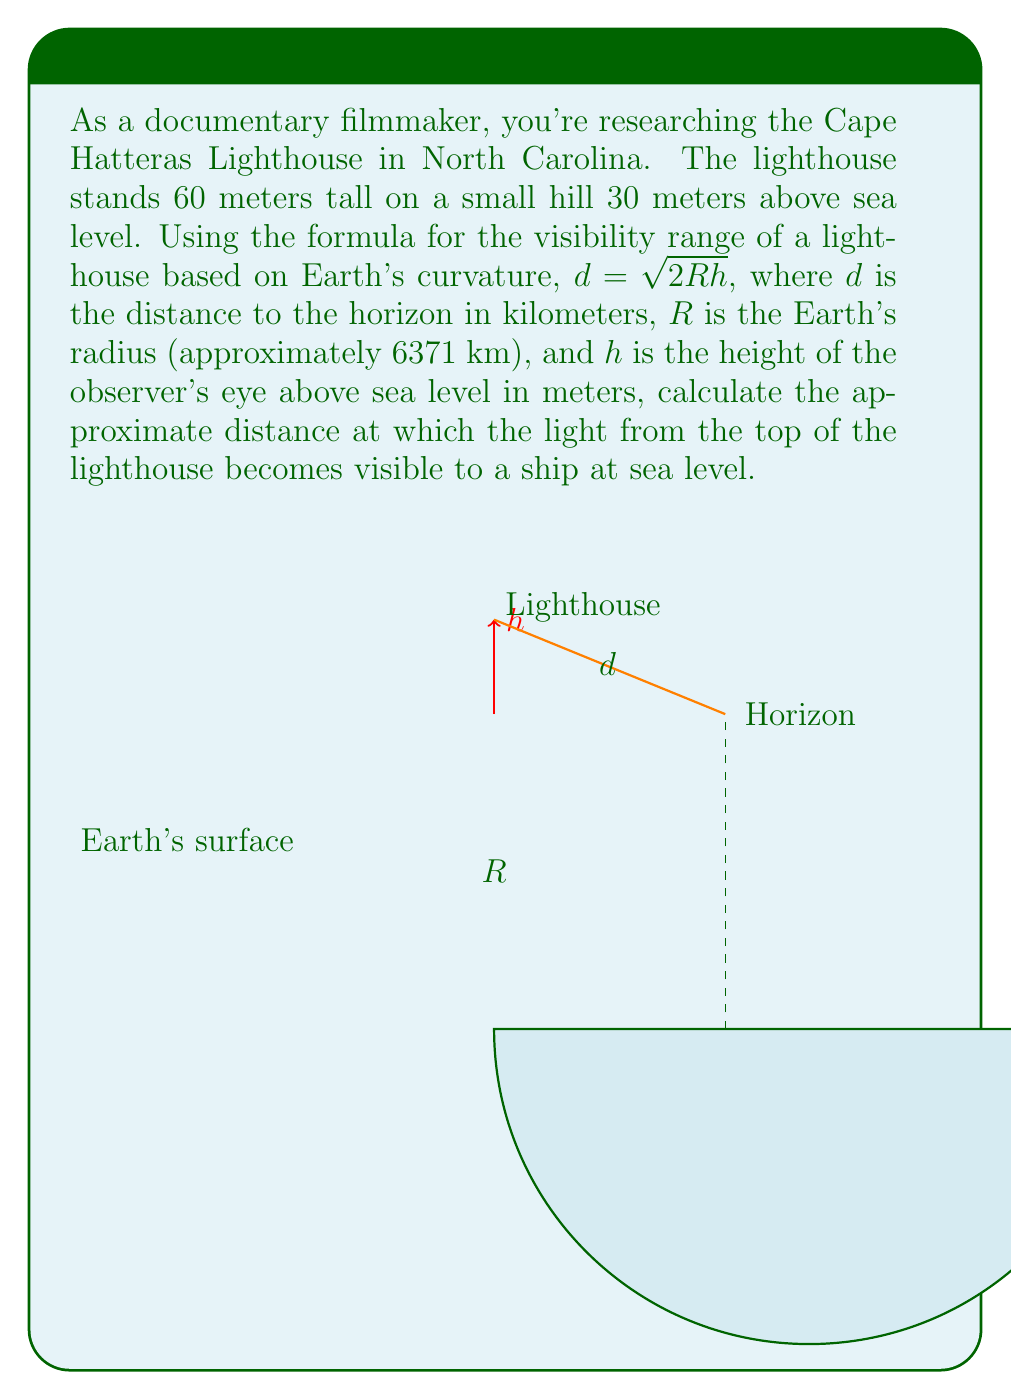Could you help me with this problem? Let's approach this step-by-step:

1) First, we need to calculate the total height of the lighthouse above sea level:
   $h = 60\text{ m} + 30\text{ m} = 90\text{ m}$

2) Now we can use the formula given:
   $d = \sqrt{2Rh}$

3) Substituting the values:
   $d = \sqrt{2 \cdot 6371\text{ km} \cdot 90\text{ m}}$

4) Convert meters to kilometers for consistency:
   $d = \sqrt{2 \cdot 6371\text{ km} \cdot 0.090\text{ km}}$

5) Calculate:
   $d = \sqrt{1146.78\text{ km}^2}$
   $d \approx 33.86\text{ km}$

6) Round to a reasonable precision for practical use:
   $d \approx 33.9\text{ km}$

This means that the light from the top of the Cape Hatteras Lighthouse would become visible to a ship at sea level when it's approximately 33.9 km away, assuming perfect visibility conditions and no other obstructions.
Answer: $33.9\text{ km}$ 